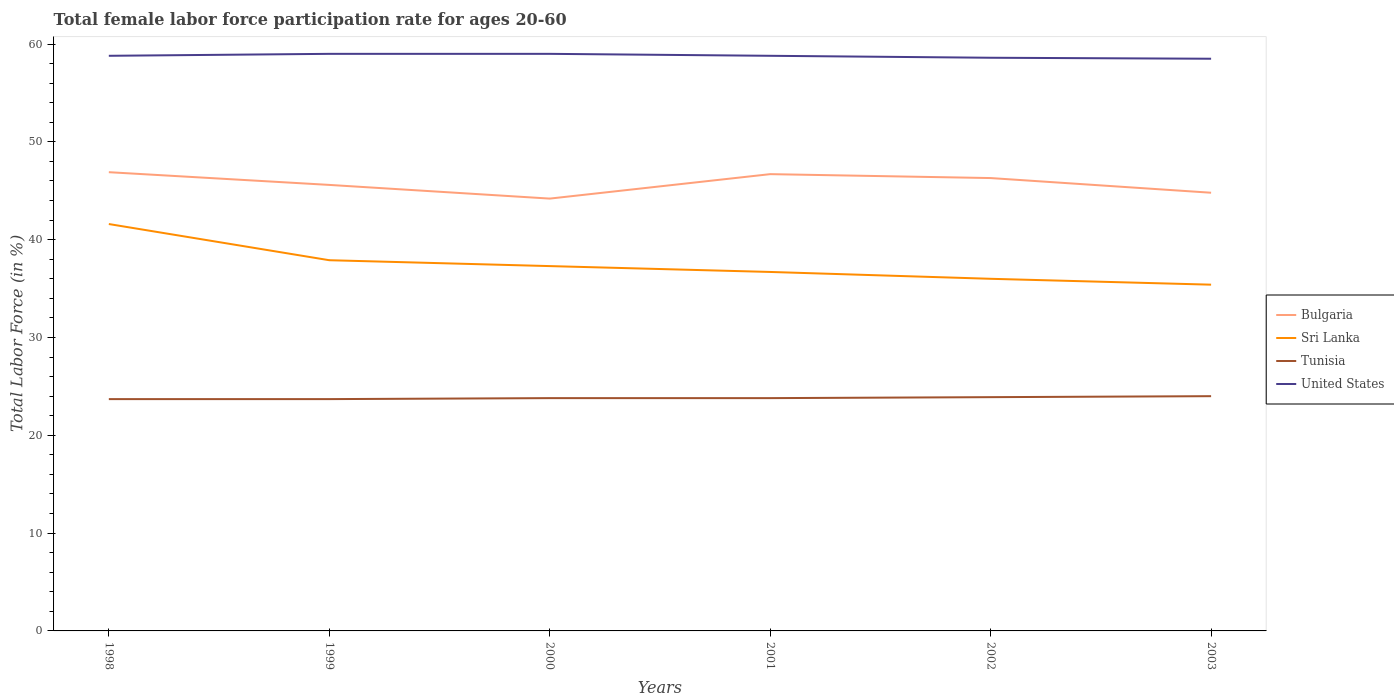Does the line corresponding to United States intersect with the line corresponding to Tunisia?
Ensure brevity in your answer.  No. Is the number of lines equal to the number of legend labels?
Provide a short and direct response. Yes. Across all years, what is the maximum female labor force participation rate in Bulgaria?
Provide a succinct answer. 44.2. In which year was the female labor force participation rate in Tunisia maximum?
Your answer should be very brief. 1998. What is the total female labor force participation rate in Tunisia in the graph?
Your response must be concise. -0.1. What is the difference between the highest and the second highest female labor force participation rate in Tunisia?
Your response must be concise. 0.3. What is the difference between the highest and the lowest female labor force participation rate in Sri Lanka?
Offer a very short reply. 2. What is the difference between two consecutive major ticks on the Y-axis?
Ensure brevity in your answer.  10. Are the values on the major ticks of Y-axis written in scientific E-notation?
Provide a short and direct response. No. Does the graph contain any zero values?
Offer a very short reply. No. How are the legend labels stacked?
Keep it short and to the point. Vertical. What is the title of the graph?
Ensure brevity in your answer.  Total female labor force participation rate for ages 20-60. What is the label or title of the X-axis?
Provide a short and direct response. Years. What is the label or title of the Y-axis?
Offer a very short reply. Total Labor Force (in %). What is the Total Labor Force (in %) in Bulgaria in 1998?
Your response must be concise. 46.9. What is the Total Labor Force (in %) in Sri Lanka in 1998?
Provide a short and direct response. 41.6. What is the Total Labor Force (in %) of Tunisia in 1998?
Your response must be concise. 23.7. What is the Total Labor Force (in %) in United States in 1998?
Your answer should be very brief. 58.8. What is the Total Labor Force (in %) of Bulgaria in 1999?
Your answer should be very brief. 45.6. What is the Total Labor Force (in %) in Sri Lanka in 1999?
Give a very brief answer. 37.9. What is the Total Labor Force (in %) of Tunisia in 1999?
Give a very brief answer. 23.7. What is the Total Labor Force (in %) in Bulgaria in 2000?
Your response must be concise. 44.2. What is the Total Labor Force (in %) in Sri Lanka in 2000?
Your answer should be compact. 37.3. What is the Total Labor Force (in %) of Tunisia in 2000?
Your response must be concise. 23.8. What is the Total Labor Force (in %) of United States in 2000?
Ensure brevity in your answer.  59. What is the Total Labor Force (in %) in Bulgaria in 2001?
Your answer should be compact. 46.7. What is the Total Labor Force (in %) in Sri Lanka in 2001?
Provide a succinct answer. 36.7. What is the Total Labor Force (in %) in Tunisia in 2001?
Offer a terse response. 23.8. What is the Total Labor Force (in %) of United States in 2001?
Provide a short and direct response. 58.8. What is the Total Labor Force (in %) in Bulgaria in 2002?
Provide a short and direct response. 46.3. What is the Total Labor Force (in %) of Sri Lanka in 2002?
Your response must be concise. 36. What is the Total Labor Force (in %) of Tunisia in 2002?
Give a very brief answer. 23.9. What is the Total Labor Force (in %) in United States in 2002?
Provide a short and direct response. 58.6. What is the Total Labor Force (in %) of Bulgaria in 2003?
Provide a short and direct response. 44.8. What is the Total Labor Force (in %) of Sri Lanka in 2003?
Ensure brevity in your answer.  35.4. What is the Total Labor Force (in %) in Tunisia in 2003?
Your answer should be compact. 24. What is the Total Labor Force (in %) in United States in 2003?
Offer a terse response. 58.5. Across all years, what is the maximum Total Labor Force (in %) in Bulgaria?
Your response must be concise. 46.9. Across all years, what is the maximum Total Labor Force (in %) of Sri Lanka?
Give a very brief answer. 41.6. Across all years, what is the maximum Total Labor Force (in %) of United States?
Your response must be concise. 59. Across all years, what is the minimum Total Labor Force (in %) in Bulgaria?
Provide a short and direct response. 44.2. Across all years, what is the minimum Total Labor Force (in %) of Sri Lanka?
Keep it short and to the point. 35.4. Across all years, what is the minimum Total Labor Force (in %) in Tunisia?
Your answer should be compact. 23.7. Across all years, what is the minimum Total Labor Force (in %) in United States?
Offer a terse response. 58.5. What is the total Total Labor Force (in %) of Bulgaria in the graph?
Provide a short and direct response. 274.5. What is the total Total Labor Force (in %) in Sri Lanka in the graph?
Offer a very short reply. 224.9. What is the total Total Labor Force (in %) in Tunisia in the graph?
Keep it short and to the point. 142.9. What is the total Total Labor Force (in %) of United States in the graph?
Provide a short and direct response. 352.7. What is the difference between the Total Labor Force (in %) of Sri Lanka in 1998 and that in 1999?
Your answer should be compact. 3.7. What is the difference between the Total Labor Force (in %) in Tunisia in 1998 and that in 1999?
Keep it short and to the point. 0. What is the difference between the Total Labor Force (in %) in United States in 1998 and that in 1999?
Make the answer very short. -0.2. What is the difference between the Total Labor Force (in %) in Sri Lanka in 1998 and that in 2000?
Provide a succinct answer. 4.3. What is the difference between the Total Labor Force (in %) in United States in 1998 and that in 2000?
Provide a succinct answer. -0.2. What is the difference between the Total Labor Force (in %) in Sri Lanka in 1998 and that in 2001?
Keep it short and to the point. 4.9. What is the difference between the Total Labor Force (in %) of Tunisia in 1998 and that in 2001?
Your response must be concise. -0.1. What is the difference between the Total Labor Force (in %) in Sri Lanka in 1998 and that in 2002?
Your answer should be very brief. 5.6. What is the difference between the Total Labor Force (in %) in Bulgaria in 1998 and that in 2003?
Your response must be concise. 2.1. What is the difference between the Total Labor Force (in %) in Sri Lanka in 1998 and that in 2003?
Keep it short and to the point. 6.2. What is the difference between the Total Labor Force (in %) in Tunisia in 1998 and that in 2003?
Your response must be concise. -0.3. What is the difference between the Total Labor Force (in %) in United States in 1998 and that in 2003?
Your answer should be compact. 0.3. What is the difference between the Total Labor Force (in %) of United States in 1999 and that in 2000?
Provide a succinct answer. 0. What is the difference between the Total Labor Force (in %) in Sri Lanka in 1999 and that in 2002?
Provide a succinct answer. 1.9. What is the difference between the Total Labor Force (in %) in United States in 1999 and that in 2002?
Your answer should be very brief. 0.4. What is the difference between the Total Labor Force (in %) of United States in 1999 and that in 2003?
Offer a terse response. 0.5. What is the difference between the Total Labor Force (in %) in Bulgaria in 2000 and that in 2001?
Make the answer very short. -2.5. What is the difference between the Total Labor Force (in %) of Tunisia in 2000 and that in 2001?
Your answer should be compact. 0. What is the difference between the Total Labor Force (in %) of United States in 2000 and that in 2001?
Offer a very short reply. 0.2. What is the difference between the Total Labor Force (in %) in Bulgaria in 2000 and that in 2002?
Give a very brief answer. -2.1. What is the difference between the Total Labor Force (in %) in Tunisia in 2000 and that in 2002?
Provide a succinct answer. -0.1. What is the difference between the Total Labor Force (in %) in United States in 2000 and that in 2002?
Offer a terse response. 0.4. What is the difference between the Total Labor Force (in %) of Sri Lanka in 2000 and that in 2003?
Give a very brief answer. 1.9. What is the difference between the Total Labor Force (in %) in United States in 2000 and that in 2003?
Offer a very short reply. 0.5. What is the difference between the Total Labor Force (in %) of Bulgaria in 2001 and that in 2002?
Offer a very short reply. 0.4. What is the difference between the Total Labor Force (in %) of Tunisia in 2001 and that in 2002?
Your answer should be very brief. -0.1. What is the difference between the Total Labor Force (in %) in United States in 2001 and that in 2002?
Make the answer very short. 0.2. What is the difference between the Total Labor Force (in %) in Bulgaria in 2001 and that in 2003?
Keep it short and to the point. 1.9. What is the difference between the Total Labor Force (in %) of Sri Lanka in 2001 and that in 2003?
Your answer should be very brief. 1.3. What is the difference between the Total Labor Force (in %) of Tunisia in 2001 and that in 2003?
Offer a terse response. -0.2. What is the difference between the Total Labor Force (in %) in Bulgaria in 1998 and the Total Labor Force (in %) in Tunisia in 1999?
Ensure brevity in your answer.  23.2. What is the difference between the Total Labor Force (in %) of Sri Lanka in 1998 and the Total Labor Force (in %) of Tunisia in 1999?
Ensure brevity in your answer.  17.9. What is the difference between the Total Labor Force (in %) of Sri Lanka in 1998 and the Total Labor Force (in %) of United States in 1999?
Provide a short and direct response. -17.4. What is the difference between the Total Labor Force (in %) in Tunisia in 1998 and the Total Labor Force (in %) in United States in 1999?
Offer a terse response. -35.3. What is the difference between the Total Labor Force (in %) in Bulgaria in 1998 and the Total Labor Force (in %) in Tunisia in 2000?
Offer a terse response. 23.1. What is the difference between the Total Labor Force (in %) in Sri Lanka in 1998 and the Total Labor Force (in %) in Tunisia in 2000?
Keep it short and to the point. 17.8. What is the difference between the Total Labor Force (in %) in Sri Lanka in 1998 and the Total Labor Force (in %) in United States in 2000?
Offer a very short reply. -17.4. What is the difference between the Total Labor Force (in %) in Tunisia in 1998 and the Total Labor Force (in %) in United States in 2000?
Make the answer very short. -35.3. What is the difference between the Total Labor Force (in %) in Bulgaria in 1998 and the Total Labor Force (in %) in Tunisia in 2001?
Your answer should be very brief. 23.1. What is the difference between the Total Labor Force (in %) of Sri Lanka in 1998 and the Total Labor Force (in %) of Tunisia in 2001?
Your answer should be compact. 17.8. What is the difference between the Total Labor Force (in %) of Sri Lanka in 1998 and the Total Labor Force (in %) of United States in 2001?
Your response must be concise. -17.2. What is the difference between the Total Labor Force (in %) of Tunisia in 1998 and the Total Labor Force (in %) of United States in 2001?
Provide a succinct answer. -35.1. What is the difference between the Total Labor Force (in %) of Sri Lanka in 1998 and the Total Labor Force (in %) of Tunisia in 2002?
Offer a very short reply. 17.7. What is the difference between the Total Labor Force (in %) in Tunisia in 1998 and the Total Labor Force (in %) in United States in 2002?
Keep it short and to the point. -34.9. What is the difference between the Total Labor Force (in %) in Bulgaria in 1998 and the Total Labor Force (in %) in Sri Lanka in 2003?
Your answer should be compact. 11.5. What is the difference between the Total Labor Force (in %) in Bulgaria in 1998 and the Total Labor Force (in %) in Tunisia in 2003?
Your answer should be very brief. 22.9. What is the difference between the Total Labor Force (in %) in Sri Lanka in 1998 and the Total Labor Force (in %) in United States in 2003?
Your response must be concise. -16.9. What is the difference between the Total Labor Force (in %) of Tunisia in 1998 and the Total Labor Force (in %) of United States in 2003?
Provide a short and direct response. -34.8. What is the difference between the Total Labor Force (in %) in Bulgaria in 1999 and the Total Labor Force (in %) in Sri Lanka in 2000?
Your answer should be compact. 8.3. What is the difference between the Total Labor Force (in %) in Bulgaria in 1999 and the Total Labor Force (in %) in Tunisia in 2000?
Your answer should be compact. 21.8. What is the difference between the Total Labor Force (in %) in Bulgaria in 1999 and the Total Labor Force (in %) in United States in 2000?
Offer a very short reply. -13.4. What is the difference between the Total Labor Force (in %) in Sri Lanka in 1999 and the Total Labor Force (in %) in United States in 2000?
Your answer should be very brief. -21.1. What is the difference between the Total Labor Force (in %) of Tunisia in 1999 and the Total Labor Force (in %) of United States in 2000?
Give a very brief answer. -35.3. What is the difference between the Total Labor Force (in %) in Bulgaria in 1999 and the Total Labor Force (in %) in Sri Lanka in 2001?
Offer a very short reply. 8.9. What is the difference between the Total Labor Force (in %) in Bulgaria in 1999 and the Total Labor Force (in %) in Tunisia in 2001?
Offer a terse response. 21.8. What is the difference between the Total Labor Force (in %) of Sri Lanka in 1999 and the Total Labor Force (in %) of Tunisia in 2001?
Provide a short and direct response. 14.1. What is the difference between the Total Labor Force (in %) in Sri Lanka in 1999 and the Total Labor Force (in %) in United States in 2001?
Provide a short and direct response. -20.9. What is the difference between the Total Labor Force (in %) of Tunisia in 1999 and the Total Labor Force (in %) of United States in 2001?
Your answer should be very brief. -35.1. What is the difference between the Total Labor Force (in %) of Bulgaria in 1999 and the Total Labor Force (in %) of Sri Lanka in 2002?
Provide a short and direct response. 9.6. What is the difference between the Total Labor Force (in %) in Bulgaria in 1999 and the Total Labor Force (in %) in Tunisia in 2002?
Your response must be concise. 21.7. What is the difference between the Total Labor Force (in %) of Sri Lanka in 1999 and the Total Labor Force (in %) of United States in 2002?
Your response must be concise. -20.7. What is the difference between the Total Labor Force (in %) of Tunisia in 1999 and the Total Labor Force (in %) of United States in 2002?
Keep it short and to the point. -34.9. What is the difference between the Total Labor Force (in %) of Bulgaria in 1999 and the Total Labor Force (in %) of Tunisia in 2003?
Your response must be concise. 21.6. What is the difference between the Total Labor Force (in %) in Sri Lanka in 1999 and the Total Labor Force (in %) in Tunisia in 2003?
Ensure brevity in your answer.  13.9. What is the difference between the Total Labor Force (in %) of Sri Lanka in 1999 and the Total Labor Force (in %) of United States in 2003?
Offer a terse response. -20.6. What is the difference between the Total Labor Force (in %) in Tunisia in 1999 and the Total Labor Force (in %) in United States in 2003?
Provide a succinct answer. -34.8. What is the difference between the Total Labor Force (in %) of Bulgaria in 2000 and the Total Labor Force (in %) of Sri Lanka in 2001?
Your answer should be compact. 7.5. What is the difference between the Total Labor Force (in %) of Bulgaria in 2000 and the Total Labor Force (in %) of Tunisia in 2001?
Your answer should be compact. 20.4. What is the difference between the Total Labor Force (in %) in Bulgaria in 2000 and the Total Labor Force (in %) in United States in 2001?
Provide a succinct answer. -14.6. What is the difference between the Total Labor Force (in %) of Sri Lanka in 2000 and the Total Labor Force (in %) of United States in 2001?
Offer a terse response. -21.5. What is the difference between the Total Labor Force (in %) in Tunisia in 2000 and the Total Labor Force (in %) in United States in 2001?
Your response must be concise. -35. What is the difference between the Total Labor Force (in %) in Bulgaria in 2000 and the Total Labor Force (in %) in Sri Lanka in 2002?
Ensure brevity in your answer.  8.2. What is the difference between the Total Labor Force (in %) of Bulgaria in 2000 and the Total Labor Force (in %) of Tunisia in 2002?
Keep it short and to the point. 20.3. What is the difference between the Total Labor Force (in %) of Bulgaria in 2000 and the Total Labor Force (in %) of United States in 2002?
Keep it short and to the point. -14.4. What is the difference between the Total Labor Force (in %) of Sri Lanka in 2000 and the Total Labor Force (in %) of United States in 2002?
Provide a short and direct response. -21.3. What is the difference between the Total Labor Force (in %) in Tunisia in 2000 and the Total Labor Force (in %) in United States in 2002?
Offer a very short reply. -34.8. What is the difference between the Total Labor Force (in %) of Bulgaria in 2000 and the Total Labor Force (in %) of Sri Lanka in 2003?
Your answer should be compact. 8.8. What is the difference between the Total Labor Force (in %) in Bulgaria in 2000 and the Total Labor Force (in %) in Tunisia in 2003?
Provide a short and direct response. 20.2. What is the difference between the Total Labor Force (in %) of Bulgaria in 2000 and the Total Labor Force (in %) of United States in 2003?
Keep it short and to the point. -14.3. What is the difference between the Total Labor Force (in %) in Sri Lanka in 2000 and the Total Labor Force (in %) in Tunisia in 2003?
Provide a short and direct response. 13.3. What is the difference between the Total Labor Force (in %) in Sri Lanka in 2000 and the Total Labor Force (in %) in United States in 2003?
Ensure brevity in your answer.  -21.2. What is the difference between the Total Labor Force (in %) in Tunisia in 2000 and the Total Labor Force (in %) in United States in 2003?
Keep it short and to the point. -34.7. What is the difference between the Total Labor Force (in %) of Bulgaria in 2001 and the Total Labor Force (in %) of Tunisia in 2002?
Offer a very short reply. 22.8. What is the difference between the Total Labor Force (in %) in Bulgaria in 2001 and the Total Labor Force (in %) in United States in 2002?
Make the answer very short. -11.9. What is the difference between the Total Labor Force (in %) in Sri Lanka in 2001 and the Total Labor Force (in %) in United States in 2002?
Keep it short and to the point. -21.9. What is the difference between the Total Labor Force (in %) of Tunisia in 2001 and the Total Labor Force (in %) of United States in 2002?
Provide a succinct answer. -34.8. What is the difference between the Total Labor Force (in %) of Bulgaria in 2001 and the Total Labor Force (in %) of Sri Lanka in 2003?
Your response must be concise. 11.3. What is the difference between the Total Labor Force (in %) in Bulgaria in 2001 and the Total Labor Force (in %) in Tunisia in 2003?
Offer a terse response. 22.7. What is the difference between the Total Labor Force (in %) in Bulgaria in 2001 and the Total Labor Force (in %) in United States in 2003?
Offer a terse response. -11.8. What is the difference between the Total Labor Force (in %) of Sri Lanka in 2001 and the Total Labor Force (in %) of Tunisia in 2003?
Offer a very short reply. 12.7. What is the difference between the Total Labor Force (in %) of Sri Lanka in 2001 and the Total Labor Force (in %) of United States in 2003?
Offer a very short reply. -21.8. What is the difference between the Total Labor Force (in %) in Tunisia in 2001 and the Total Labor Force (in %) in United States in 2003?
Keep it short and to the point. -34.7. What is the difference between the Total Labor Force (in %) of Bulgaria in 2002 and the Total Labor Force (in %) of Tunisia in 2003?
Provide a short and direct response. 22.3. What is the difference between the Total Labor Force (in %) in Sri Lanka in 2002 and the Total Labor Force (in %) in Tunisia in 2003?
Your answer should be very brief. 12. What is the difference between the Total Labor Force (in %) in Sri Lanka in 2002 and the Total Labor Force (in %) in United States in 2003?
Make the answer very short. -22.5. What is the difference between the Total Labor Force (in %) of Tunisia in 2002 and the Total Labor Force (in %) of United States in 2003?
Your answer should be compact. -34.6. What is the average Total Labor Force (in %) in Bulgaria per year?
Ensure brevity in your answer.  45.75. What is the average Total Labor Force (in %) of Sri Lanka per year?
Provide a succinct answer. 37.48. What is the average Total Labor Force (in %) of Tunisia per year?
Provide a short and direct response. 23.82. What is the average Total Labor Force (in %) of United States per year?
Your answer should be compact. 58.78. In the year 1998, what is the difference between the Total Labor Force (in %) of Bulgaria and Total Labor Force (in %) of Tunisia?
Offer a terse response. 23.2. In the year 1998, what is the difference between the Total Labor Force (in %) in Bulgaria and Total Labor Force (in %) in United States?
Your answer should be compact. -11.9. In the year 1998, what is the difference between the Total Labor Force (in %) in Sri Lanka and Total Labor Force (in %) in United States?
Make the answer very short. -17.2. In the year 1998, what is the difference between the Total Labor Force (in %) in Tunisia and Total Labor Force (in %) in United States?
Provide a succinct answer. -35.1. In the year 1999, what is the difference between the Total Labor Force (in %) in Bulgaria and Total Labor Force (in %) in Sri Lanka?
Your answer should be very brief. 7.7. In the year 1999, what is the difference between the Total Labor Force (in %) of Bulgaria and Total Labor Force (in %) of Tunisia?
Provide a short and direct response. 21.9. In the year 1999, what is the difference between the Total Labor Force (in %) of Bulgaria and Total Labor Force (in %) of United States?
Provide a short and direct response. -13.4. In the year 1999, what is the difference between the Total Labor Force (in %) in Sri Lanka and Total Labor Force (in %) in United States?
Your answer should be compact. -21.1. In the year 1999, what is the difference between the Total Labor Force (in %) in Tunisia and Total Labor Force (in %) in United States?
Ensure brevity in your answer.  -35.3. In the year 2000, what is the difference between the Total Labor Force (in %) in Bulgaria and Total Labor Force (in %) in Sri Lanka?
Provide a succinct answer. 6.9. In the year 2000, what is the difference between the Total Labor Force (in %) of Bulgaria and Total Labor Force (in %) of Tunisia?
Make the answer very short. 20.4. In the year 2000, what is the difference between the Total Labor Force (in %) in Bulgaria and Total Labor Force (in %) in United States?
Keep it short and to the point. -14.8. In the year 2000, what is the difference between the Total Labor Force (in %) of Sri Lanka and Total Labor Force (in %) of Tunisia?
Your answer should be compact. 13.5. In the year 2000, what is the difference between the Total Labor Force (in %) of Sri Lanka and Total Labor Force (in %) of United States?
Ensure brevity in your answer.  -21.7. In the year 2000, what is the difference between the Total Labor Force (in %) of Tunisia and Total Labor Force (in %) of United States?
Make the answer very short. -35.2. In the year 2001, what is the difference between the Total Labor Force (in %) in Bulgaria and Total Labor Force (in %) in Sri Lanka?
Your response must be concise. 10. In the year 2001, what is the difference between the Total Labor Force (in %) of Bulgaria and Total Labor Force (in %) of Tunisia?
Provide a succinct answer. 22.9. In the year 2001, what is the difference between the Total Labor Force (in %) of Bulgaria and Total Labor Force (in %) of United States?
Make the answer very short. -12.1. In the year 2001, what is the difference between the Total Labor Force (in %) of Sri Lanka and Total Labor Force (in %) of Tunisia?
Offer a terse response. 12.9. In the year 2001, what is the difference between the Total Labor Force (in %) of Sri Lanka and Total Labor Force (in %) of United States?
Give a very brief answer. -22.1. In the year 2001, what is the difference between the Total Labor Force (in %) in Tunisia and Total Labor Force (in %) in United States?
Provide a succinct answer. -35. In the year 2002, what is the difference between the Total Labor Force (in %) in Bulgaria and Total Labor Force (in %) in Sri Lanka?
Make the answer very short. 10.3. In the year 2002, what is the difference between the Total Labor Force (in %) in Bulgaria and Total Labor Force (in %) in Tunisia?
Keep it short and to the point. 22.4. In the year 2002, what is the difference between the Total Labor Force (in %) in Sri Lanka and Total Labor Force (in %) in Tunisia?
Make the answer very short. 12.1. In the year 2002, what is the difference between the Total Labor Force (in %) in Sri Lanka and Total Labor Force (in %) in United States?
Keep it short and to the point. -22.6. In the year 2002, what is the difference between the Total Labor Force (in %) of Tunisia and Total Labor Force (in %) of United States?
Offer a terse response. -34.7. In the year 2003, what is the difference between the Total Labor Force (in %) of Bulgaria and Total Labor Force (in %) of Tunisia?
Ensure brevity in your answer.  20.8. In the year 2003, what is the difference between the Total Labor Force (in %) of Bulgaria and Total Labor Force (in %) of United States?
Your answer should be very brief. -13.7. In the year 2003, what is the difference between the Total Labor Force (in %) in Sri Lanka and Total Labor Force (in %) in Tunisia?
Ensure brevity in your answer.  11.4. In the year 2003, what is the difference between the Total Labor Force (in %) in Sri Lanka and Total Labor Force (in %) in United States?
Ensure brevity in your answer.  -23.1. In the year 2003, what is the difference between the Total Labor Force (in %) of Tunisia and Total Labor Force (in %) of United States?
Your response must be concise. -34.5. What is the ratio of the Total Labor Force (in %) in Bulgaria in 1998 to that in 1999?
Keep it short and to the point. 1.03. What is the ratio of the Total Labor Force (in %) of Sri Lanka in 1998 to that in 1999?
Your answer should be compact. 1.1. What is the ratio of the Total Labor Force (in %) in Bulgaria in 1998 to that in 2000?
Your response must be concise. 1.06. What is the ratio of the Total Labor Force (in %) in Sri Lanka in 1998 to that in 2000?
Your answer should be compact. 1.12. What is the ratio of the Total Labor Force (in %) in Tunisia in 1998 to that in 2000?
Ensure brevity in your answer.  1. What is the ratio of the Total Labor Force (in %) in Sri Lanka in 1998 to that in 2001?
Give a very brief answer. 1.13. What is the ratio of the Total Labor Force (in %) in United States in 1998 to that in 2001?
Provide a succinct answer. 1. What is the ratio of the Total Labor Force (in %) of Sri Lanka in 1998 to that in 2002?
Provide a short and direct response. 1.16. What is the ratio of the Total Labor Force (in %) in United States in 1998 to that in 2002?
Your answer should be compact. 1. What is the ratio of the Total Labor Force (in %) of Bulgaria in 1998 to that in 2003?
Your response must be concise. 1.05. What is the ratio of the Total Labor Force (in %) in Sri Lanka in 1998 to that in 2003?
Keep it short and to the point. 1.18. What is the ratio of the Total Labor Force (in %) in Tunisia in 1998 to that in 2003?
Your answer should be compact. 0.99. What is the ratio of the Total Labor Force (in %) of United States in 1998 to that in 2003?
Offer a very short reply. 1.01. What is the ratio of the Total Labor Force (in %) in Bulgaria in 1999 to that in 2000?
Provide a short and direct response. 1.03. What is the ratio of the Total Labor Force (in %) in Sri Lanka in 1999 to that in 2000?
Your response must be concise. 1.02. What is the ratio of the Total Labor Force (in %) in Tunisia in 1999 to that in 2000?
Offer a very short reply. 1. What is the ratio of the Total Labor Force (in %) in Bulgaria in 1999 to that in 2001?
Give a very brief answer. 0.98. What is the ratio of the Total Labor Force (in %) of Sri Lanka in 1999 to that in 2001?
Ensure brevity in your answer.  1.03. What is the ratio of the Total Labor Force (in %) of Tunisia in 1999 to that in 2001?
Keep it short and to the point. 1. What is the ratio of the Total Labor Force (in %) of United States in 1999 to that in 2001?
Offer a terse response. 1. What is the ratio of the Total Labor Force (in %) of Bulgaria in 1999 to that in 2002?
Ensure brevity in your answer.  0.98. What is the ratio of the Total Labor Force (in %) in Sri Lanka in 1999 to that in 2002?
Your answer should be compact. 1.05. What is the ratio of the Total Labor Force (in %) in Tunisia in 1999 to that in 2002?
Keep it short and to the point. 0.99. What is the ratio of the Total Labor Force (in %) of United States in 1999 to that in 2002?
Offer a terse response. 1.01. What is the ratio of the Total Labor Force (in %) of Bulgaria in 1999 to that in 2003?
Ensure brevity in your answer.  1.02. What is the ratio of the Total Labor Force (in %) of Sri Lanka in 1999 to that in 2003?
Give a very brief answer. 1.07. What is the ratio of the Total Labor Force (in %) of Tunisia in 1999 to that in 2003?
Make the answer very short. 0.99. What is the ratio of the Total Labor Force (in %) of United States in 1999 to that in 2003?
Offer a terse response. 1.01. What is the ratio of the Total Labor Force (in %) of Bulgaria in 2000 to that in 2001?
Your answer should be very brief. 0.95. What is the ratio of the Total Labor Force (in %) of Sri Lanka in 2000 to that in 2001?
Your response must be concise. 1.02. What is the ratio of the Total Labor Force (in %) in Bulgaria in 2000 to that in 2002?
Keep it short and to the point. 0.95. What is the ratio of the Total Labor Force (in %) in Sri Lanka in 2000 to that in 2002?
Make the answer very short. 1.04. What is the ratio of the Total Labor Force (in %) in Tunisia in 2000 to that in 2002?
Provide a succinct answer. 1. What is the ratio of the Total Labor Force (in %) of United States in 2000 to that in 2002?
Your answer should be very brief. 1.01. What is the ratio of the Total Labor Force (in %) in Bulgaria in 2000 to that in 2003?
Offer a very short reply. 0.99. What is the ratio of the Total Labor Force (in %) in Sri Lanka in 2000 to that in 2003?
Your answer should be very brief. 1.05. What is the ratio of the Total Labor Force (in %) in Tunisia in 2000 to that in 2003?
Your response must be concise. 0.99. What is the ratio of the Total Labor Force (in %) in United States in 2000 to that in 2003?
Make the answer very short. 1.01. What is the ratio of the Total Labor Force (in %) of Bulgaria in 2001 to that in 2002?
Ensure brevity in your answer.  1.01. What is the ratio of the Total Labor Force (in %) in Sri Lanka in 2001 to that in 2002?
Your answer should be compact. 1.02. What is the ratio of the Total Labor Force (in %) in Bulgaria in 2001 to that in 2003?
Ensure brevity in your answer.  1.04. What is the ratio of the Total Labor Force (in %) of Sri Lanka in 2001 to that in 2003?
Your answer should be compact. 1.04. What is the ratio of the Total Labor Force (in %) of Bulgaria in 2002 to that in 2003?
Your answer should be compact. 1.03. What is the ratio of the Total Labor Force (in %) of Sri Lanka in 2002 to that in 2003?
Keep it short and to the point. 1.02. What is the ratio of the Total Labor Force (in %) in Tunisia in 2002 to that in 2003?
Ensure brevity in your answer.  1. What is the difference between the highest and the second highest Total Labor Force (in %) of United States?
Give a very brief answer. 0. What is the difference between the highest and the lowest Total Labor Force (in %) in Bulgaria?
Keep it short and to the point. 2.7. 